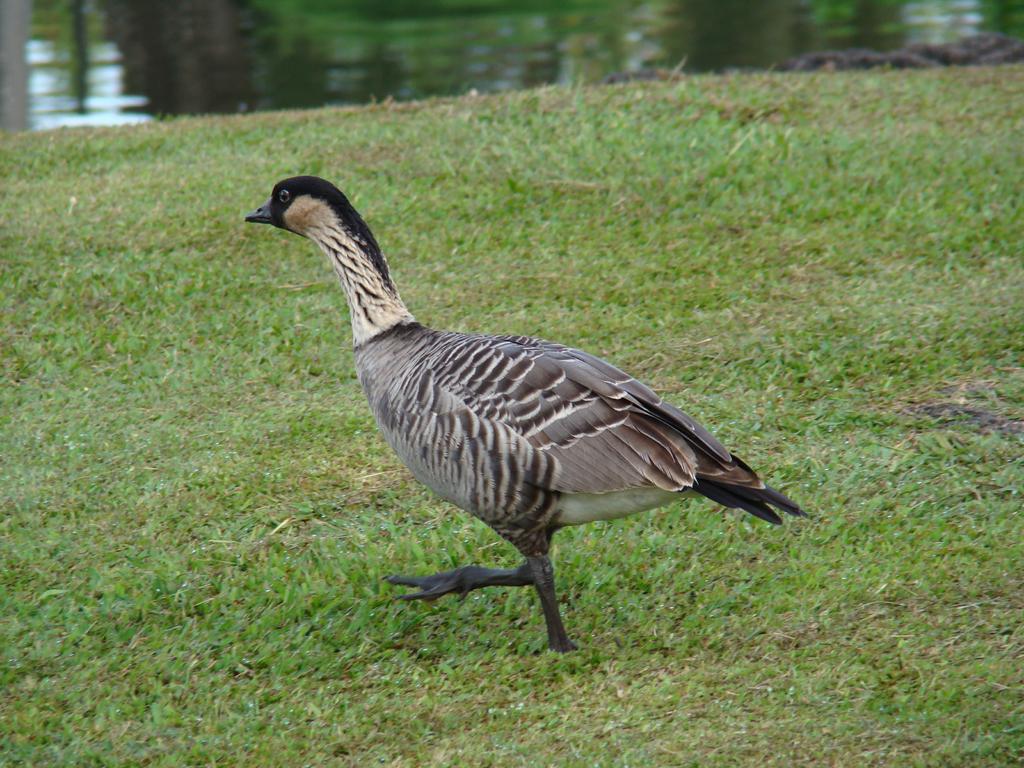Describe this image in one or two sentences. In this picture I can see a duck standing on the grass, and in the background there is water. 